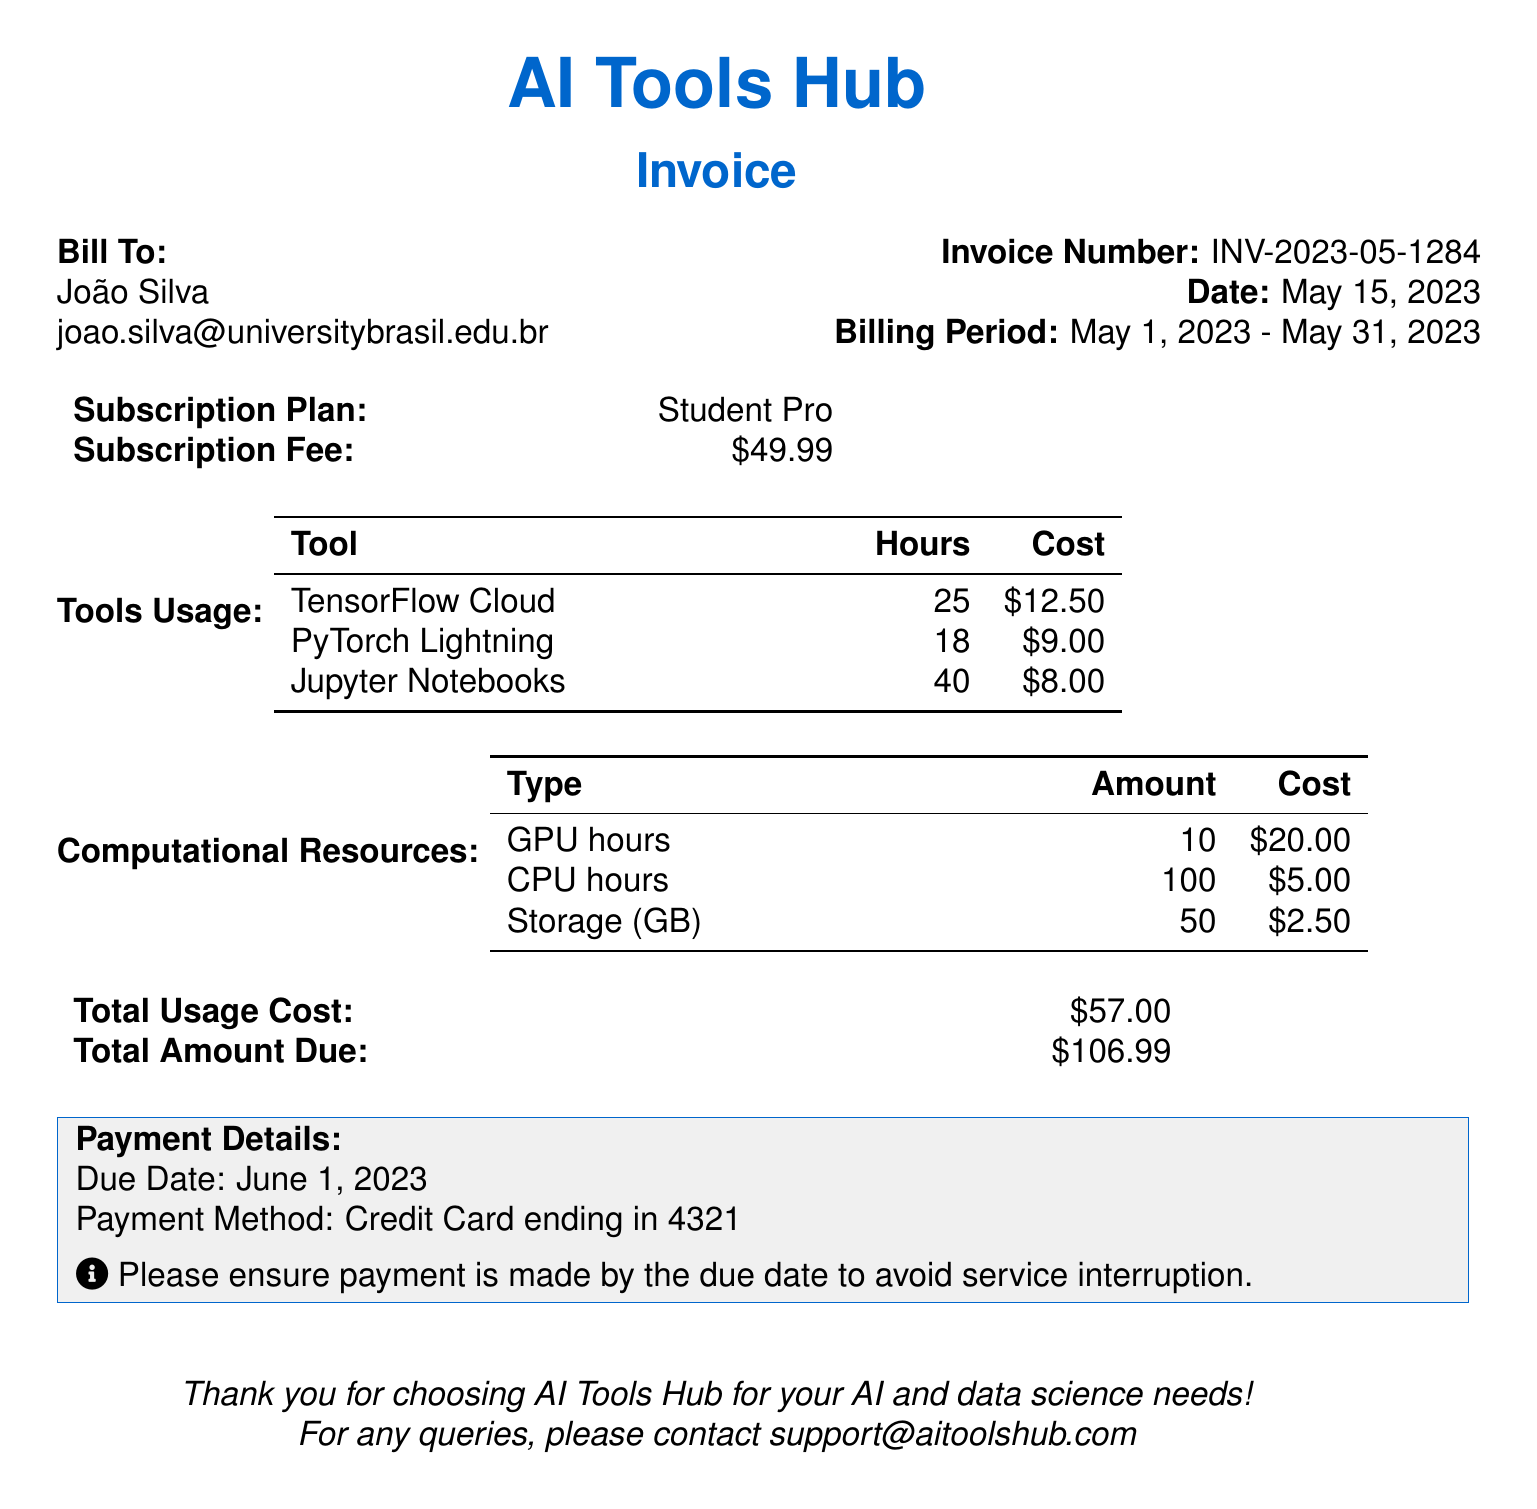what is the invoice number? The invoice number is clearly stated in the document under "Invoice Number."
Answer: INV-2023-05-1284 who is the bill addressed to? The document includes the name of the person being billed in the "Bill To" section.
Answer: João Silva what is the billing period? The billing period is stated in the document as the time frame for which the services were billed.
Answer: May 1, 2023 - May 31, 2023 what is the total amount due? The total amount due is calculated at the end of the invoice.
Answer: $106.99 how many GPU hours were used? The number of GPU hours used is indicated in the "Computational Resources" section of the document.
Answer: 10 what is the usage cost for Jupyter Notebooks? The cost for using Jupyter Notebooks is detailed in the "Tools Usage" section.
Answer: $8.00 what payment method is specified? The payment method is mentioned in the "Payment Details" section of the invoice.
Answer: Credit Card ending in 4321 when is the due date for payment? The due date is provided in the "Payment Details" section of the document.
Answer: June 1, 2023 what subscription plan is mentioned? The subscription plan is listed under the "Subscription Plan" section in the document.
Answer: Student Pro 